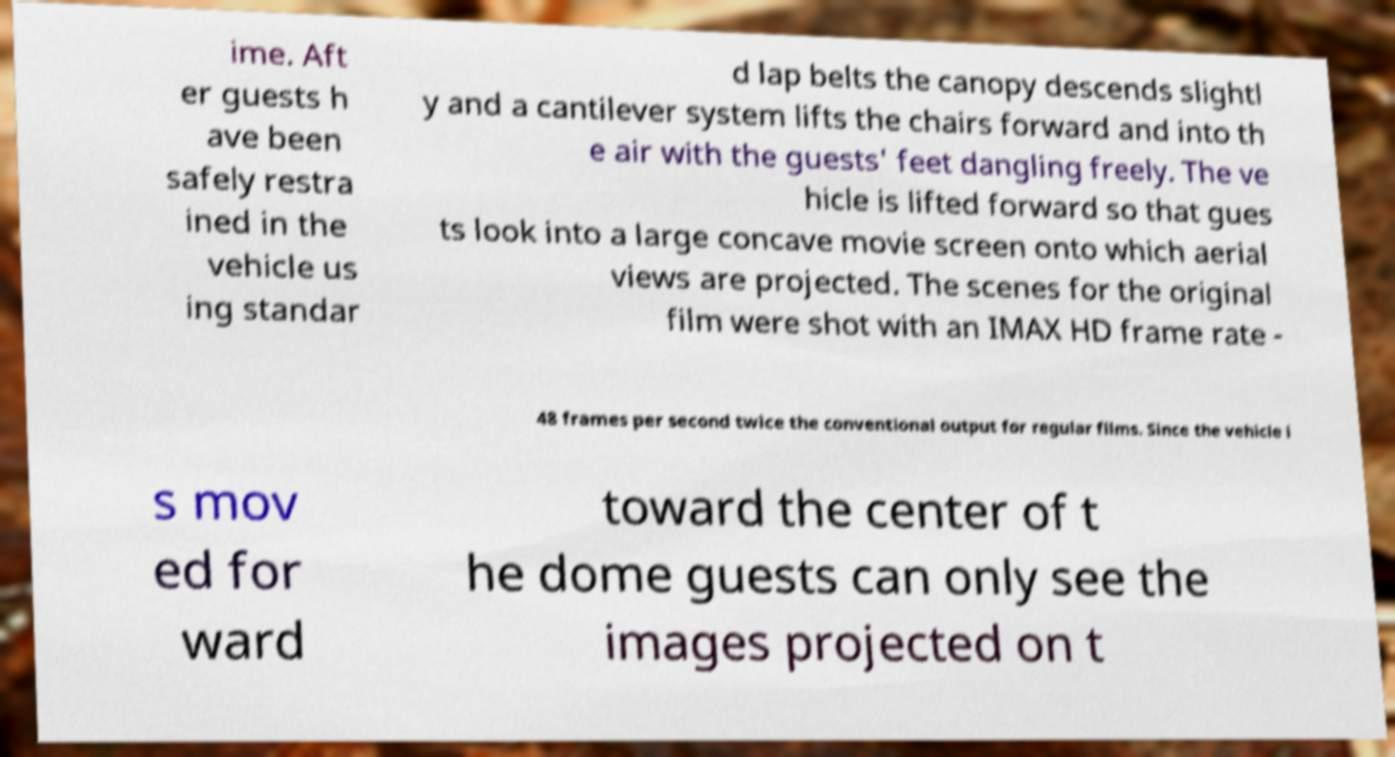Please read and relay the text visible in this image. What does it say? ime. Aft er guests h ave been safely restra ined in the vehicle us ing standar d lap belts the canopy descends slightl y and a cantilever system lifts the chairs forward and into th e air with the guests' feet dangling freely. The ve hicle is lifted forward so that gues ts look into a large concave movie screen onto which aerial views are projected. The scenes for the original film were shot with an IMAX HD frame rate - 48 frames per second twice the conventional output for regular films. Since the vehicle i s mov ed for ward toward the center of t he dome guests can only see the images projected on t 